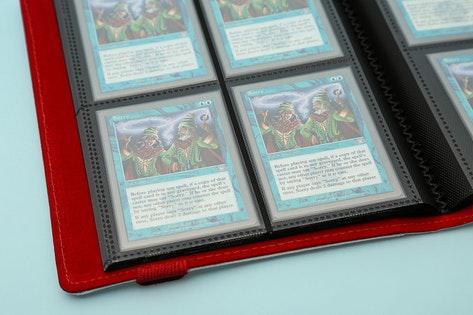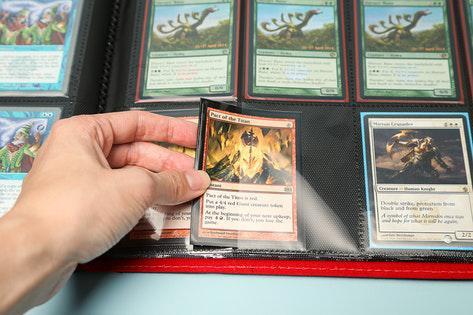The first image is the image on the left, the second image is the image on the right. Considering the images on both sides, is "One binder is bright blue." valid? Answer yes or no. No. 